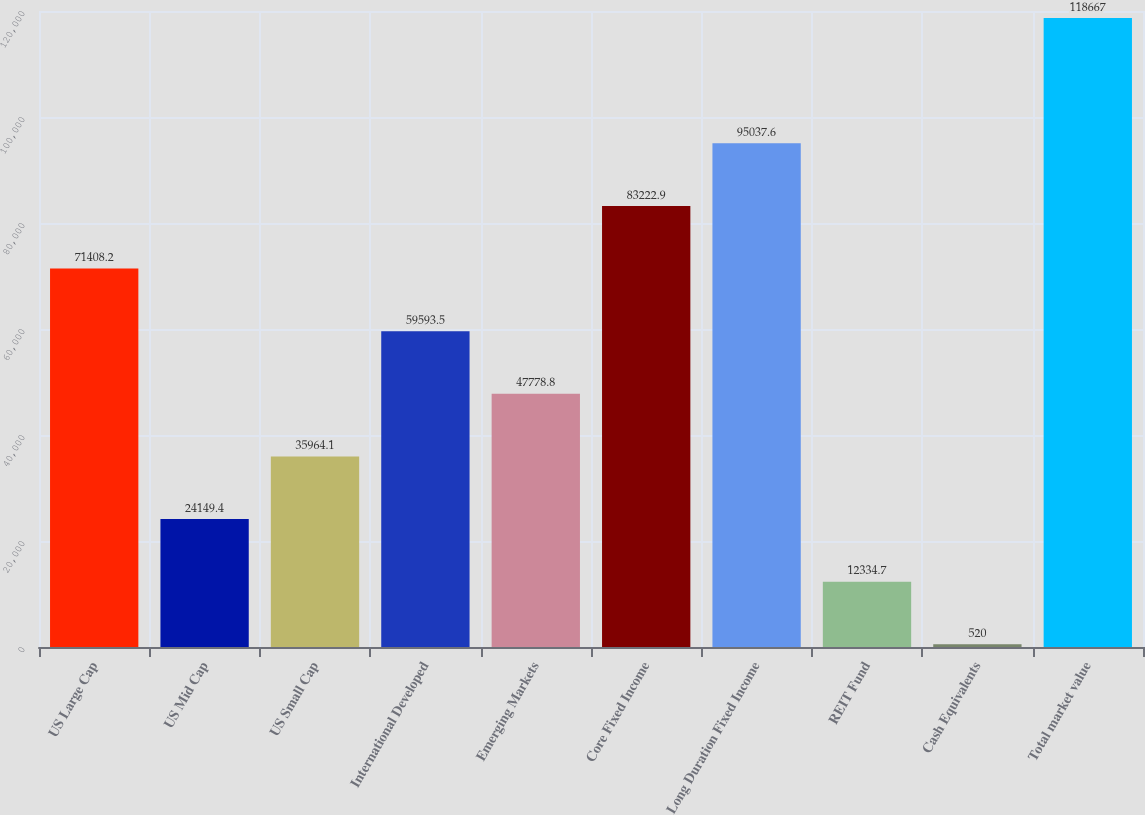Convert chart to OTSL. <chart><loc_0><loc_0><loc_500><loc_500><bar_chart><fcel>US Large Cap<fcel>US Mid Cap<fcel>US Small Cap<fcel>International Developed<fcel>Emerging Markets<fcel>Core Fixed Income<fcel>Long Duration Fixed Income<fcel>REIT Fund<fcel>Cash Equivalents<fcel>Total market value<nl><fcel>71408.2<fcel>24149.4<fcel>35964.1<fcel>59593.5<fcel>47778.8<fcel>83222.9<fcel>95037.6<fcel>12334.7<fcel>520<fcel>118667<nl></chart> 